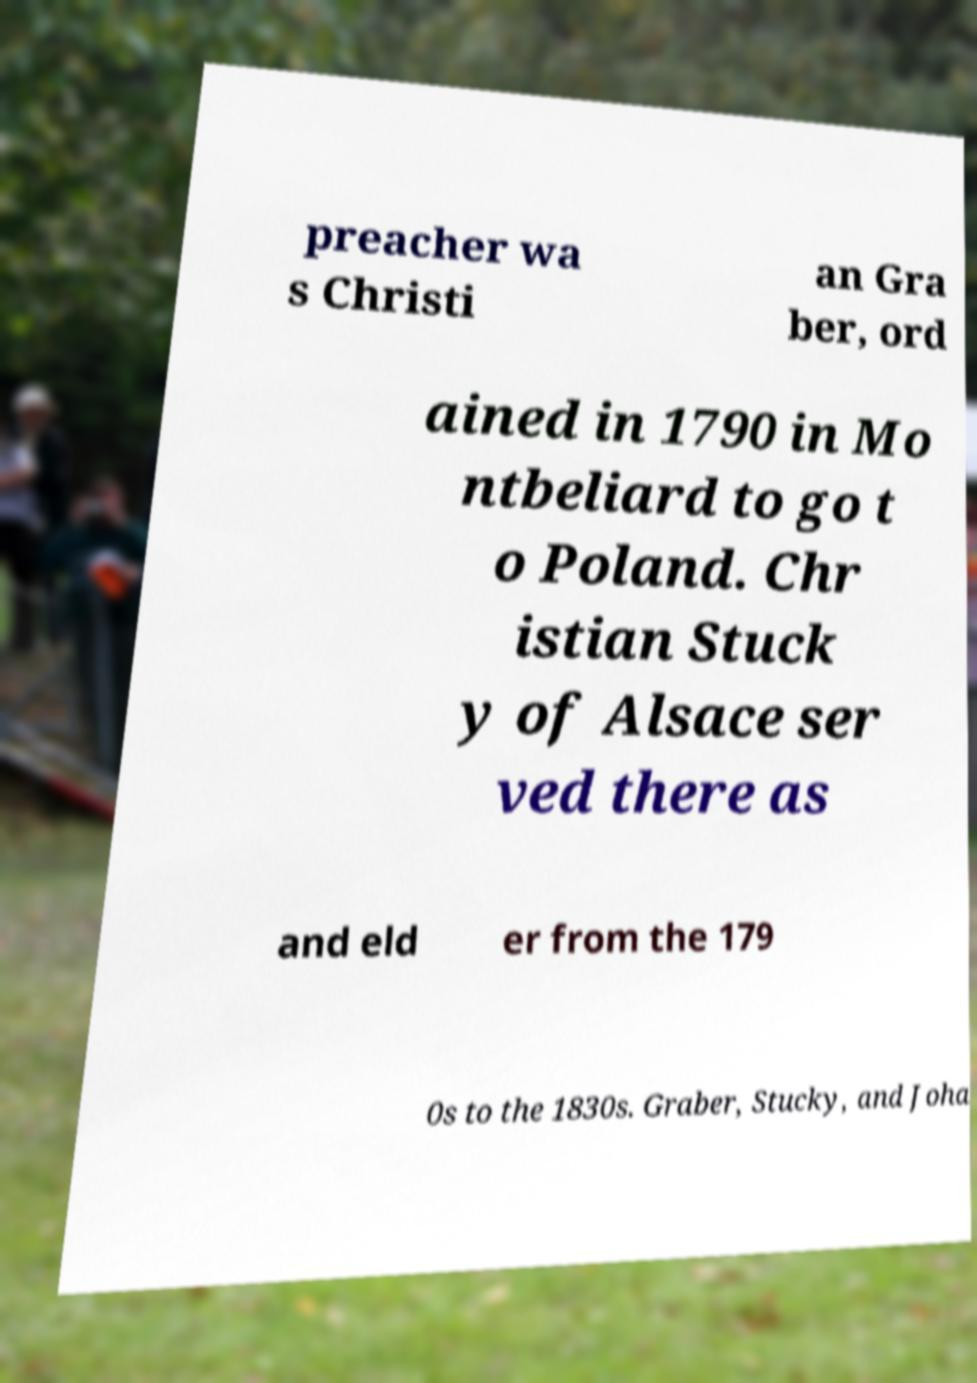There's text embedded in this image that I need extracted. Can you transcribe it verbatim? preacher wa s Christi an Gra ber, ord ained in 1790 in Mo ntbeliard to go t o Poland. Chr istian Stuck y of Alsace ser ved there as and eld er from the 179 0s to the 1830s. Graber, Stucky, and Joha 